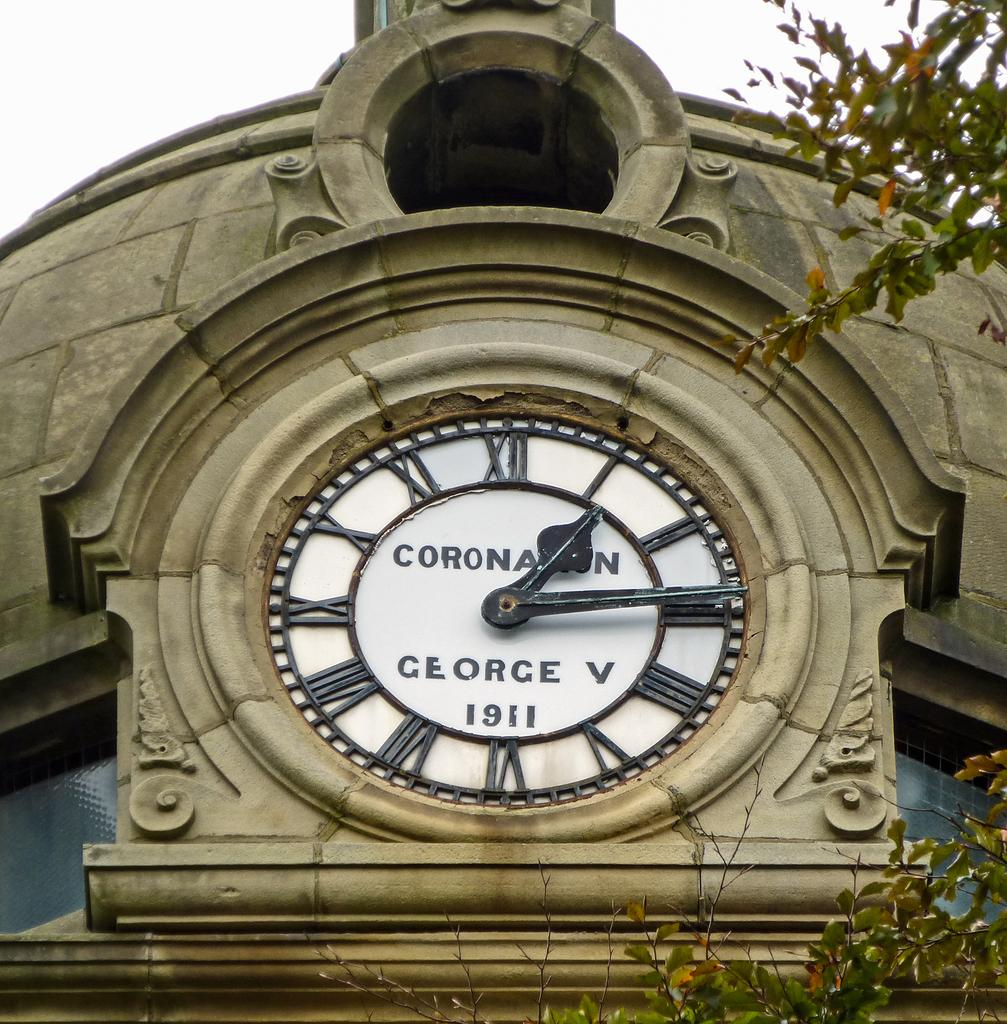<image>
Present a compact description of the photo's key features. A clock was dedicated to george the fifth in 1911. 